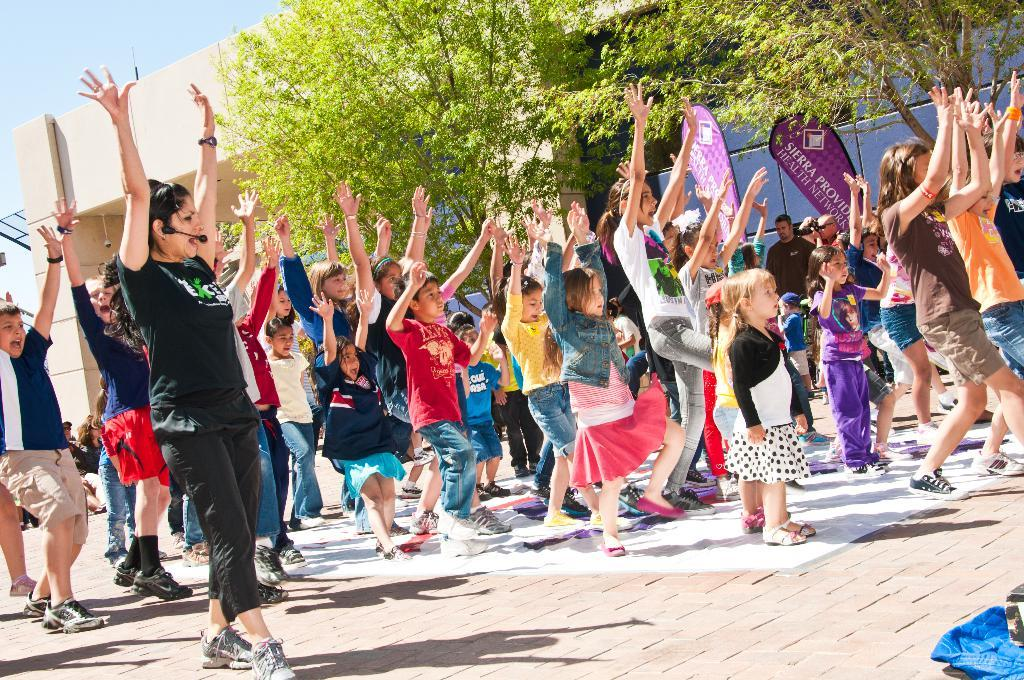What is the main subject of the image? The main subject of the image is a group of people standing. What additional objects can be seen in the image? There are advertising flags and trees in the image. What type of structure is depicted in the image? The image appears to depict a house. What can be seen in the background of the image? The sky is visible in the background of the image. What type of plate is being used by the brother in the image? There is no brother or plate present in the image. 